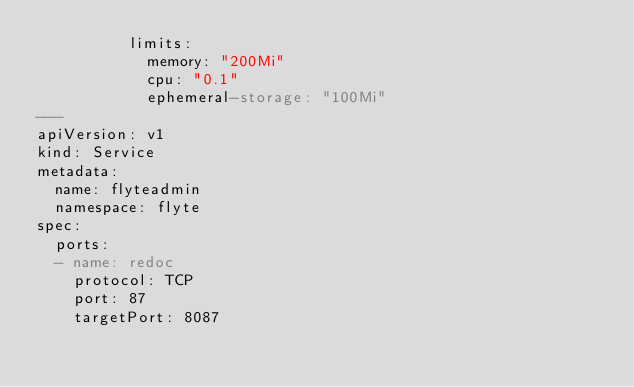Convert code to text. <code><loc_0><loc_0><loc_500><loc_500><_YAML_>          limits:
            memory: "200Mi"
            cpu: "0.1"
            ephemeral-storage: "100Mi"
---
apiVersion: v1
kind: Service
metadata:
  name: flyteadmin
  namespace: flyte
spec:
  ports:
  - name: redoc
    protocol: TCP
    port: 87
    targetPort: 8087
</code> 